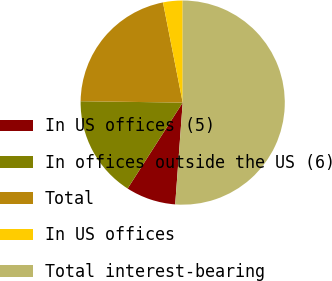<chart> <loc_0><loc_0><loc_500><loc_500><pie_chart><fcel>In US offices (5)<fcel>In offices outside the US (6)<fcel>Total<fcel>In US offices<fcel>Total interest-bearing<nl><fcel>7.9%<fcel>16.14%<fcel>21.69%<fcel>3.09%<fcel>51.17%<nl></chart> 